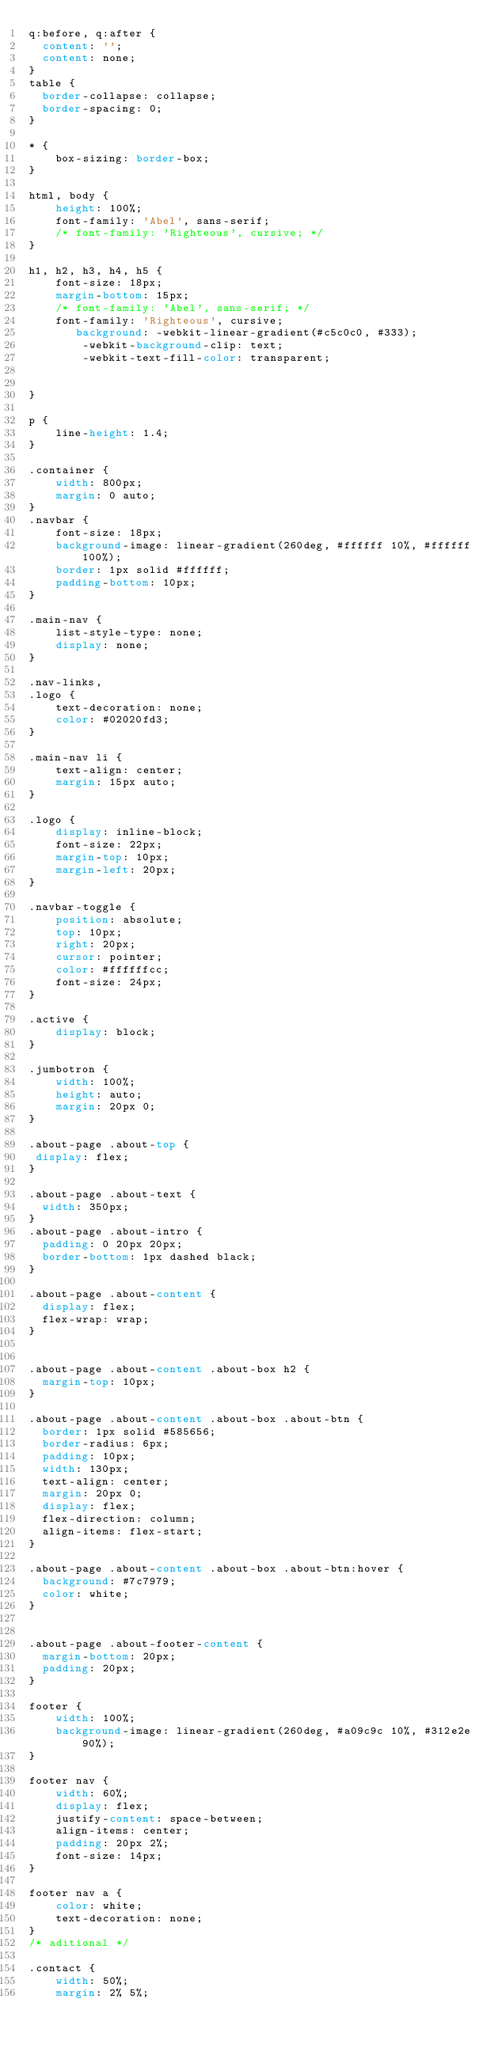<code> <loc_0><loc_0><loc_500><loc_500><_CSS_>q:before, q:after {
	content: '';
	content: none;
}
table {
	border-collapse: collapse;
	border-spacing: 0;
}

* {
    box-sizing: border-box;
}

html, body {
    height: 100%;
    font-family: 'Abel', sans-serif;
    /* font-family: 'Righteous', cursive; */
}

h1, h2, h3, h4, h5 {
    font-size: 18px;
    margin-bottom: 15px;
    /* font-family: 'Abel', sans-serif; */
    font-family: 'Righteous', cursive;
       background: -webkit-linear-gradient(#c5c0c0, #333);
        -webkit-background-clip: text;
        -webkit-text-fill-color: transparent;


}

p {
    line-height: 1.4;
}

.container {
    width: 800px;
    margin: 0 auto;
}
.navbar {
    font-size: 18px;
    background-image: linear-gradient(260deg, #ffffff 10%, #ffffff 100%);
    border: 1px solid #ffffff;
    padding-bottom: 10px;
}

.main-nav {
    list-style-type: none;
    display: none;
}

.nav-links,
.logo {
    text-decoration: none;
    color: #02020fd3;
}

.main-nav li {
    text-align: center;
    margin: 15px auto;
}

.logo {
    display: inline-block;
    font-size: 22px;
    margin-top: 10px;
    margin-left: 20px;
}

.navbar-toggle {
    position: absolute;
    top: 10px;
    right: 20px;
    cursor: pointer;
    color: #ffffffcc;
    font-size: 24px;
}

.active {
    display: block;
}

.jumbotron {
    width: 100%;
    height: auto;
    margin: 20px 0;
}

.about-page .about-top {
 display: flex;
}

.about-page .about-text {
  width: 350px;
}
.about-page .about-intro {
  padding: 0 20px 20px;
  border-bottom: 1px dashed black;
}

.about-page .about-content {
  display: flex;
  flex-wrap: wrap;
}


.about-page .about-content .about-box h2 {
  margin-top: 10px;
}

.about-page .about-content .about-box .about-btn {
  border: 1px solid #585656;
  border-radius: 6px;
  padding: 10px;
  width: 130px;
  text-align: center;
  margin: 20px 0;
  display: flex;
  flex-direction: column;
  align-items: flex-start;
}

.about-page .about-content .about-box .about-btn:hover {
  background: #7c7979;
  color: white;
}


.about-page .about-footer-content {
  margin-bottom: 20px;
  padding: 20px;
}

footer {
    width: 100%;
    background-image: linear-gradient(260deg, #a09c9c 10%, #312e2e 90%);
}

footer nav {
    width: 60%;
    display: flex;
    justify-content: space-between;
    align-items: center;
    padding: 20px 2%;
    font-size: 14px;
}

footer nav a {
    color: white;
    text-decoration: none;
}
/* aditional */

.contact {
    width: 50%;
    margin: 2% 5%;</code> 